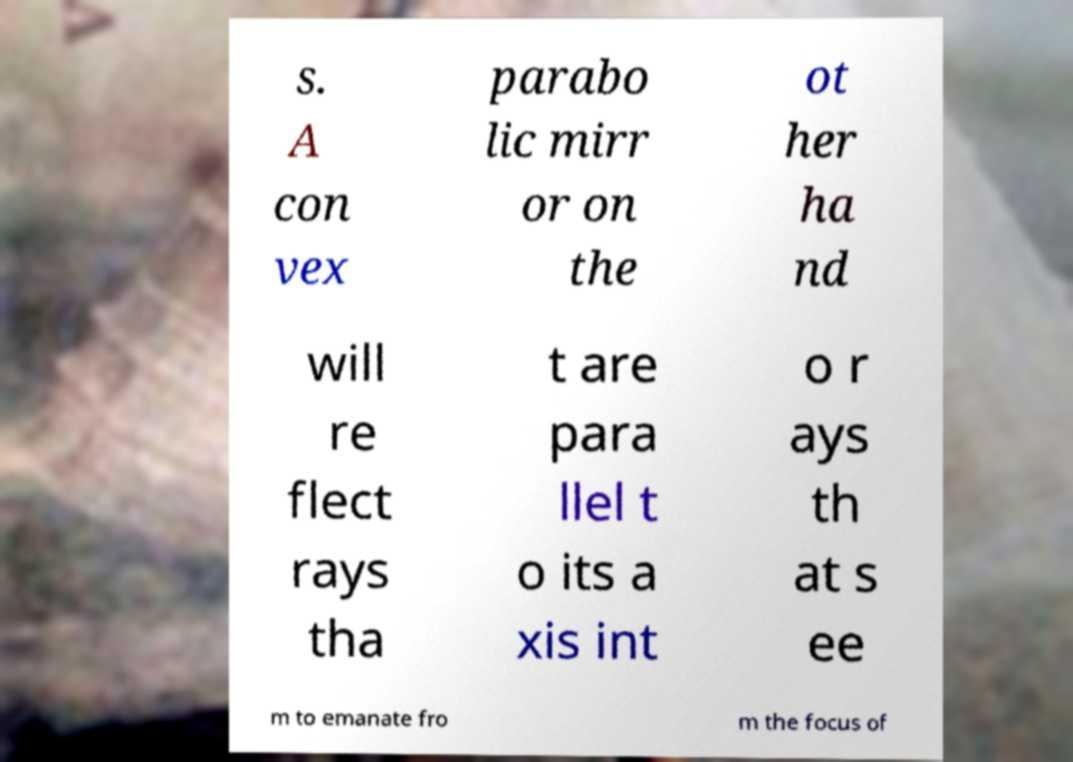Can you accurately transcribe the text from the provided image for me? s. A con vex parabo lic mirr or on the ot her ha nd will re flect rays tha t are para llel t o its a xis int o r ays th at s ee m to emanate fro m the focus of 